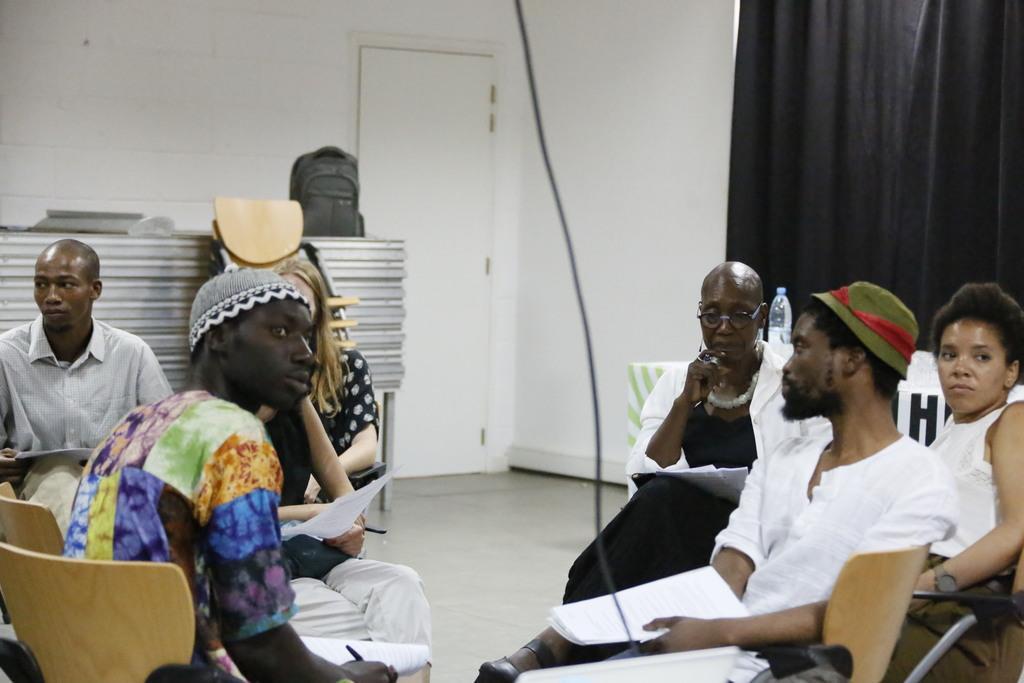Can you describe this image briefly? In this picture we can see some people sitting on chairs, holding papers with their hands and in the background we can see the floor, bag, wall, door, chairs, curtain, some objects. 